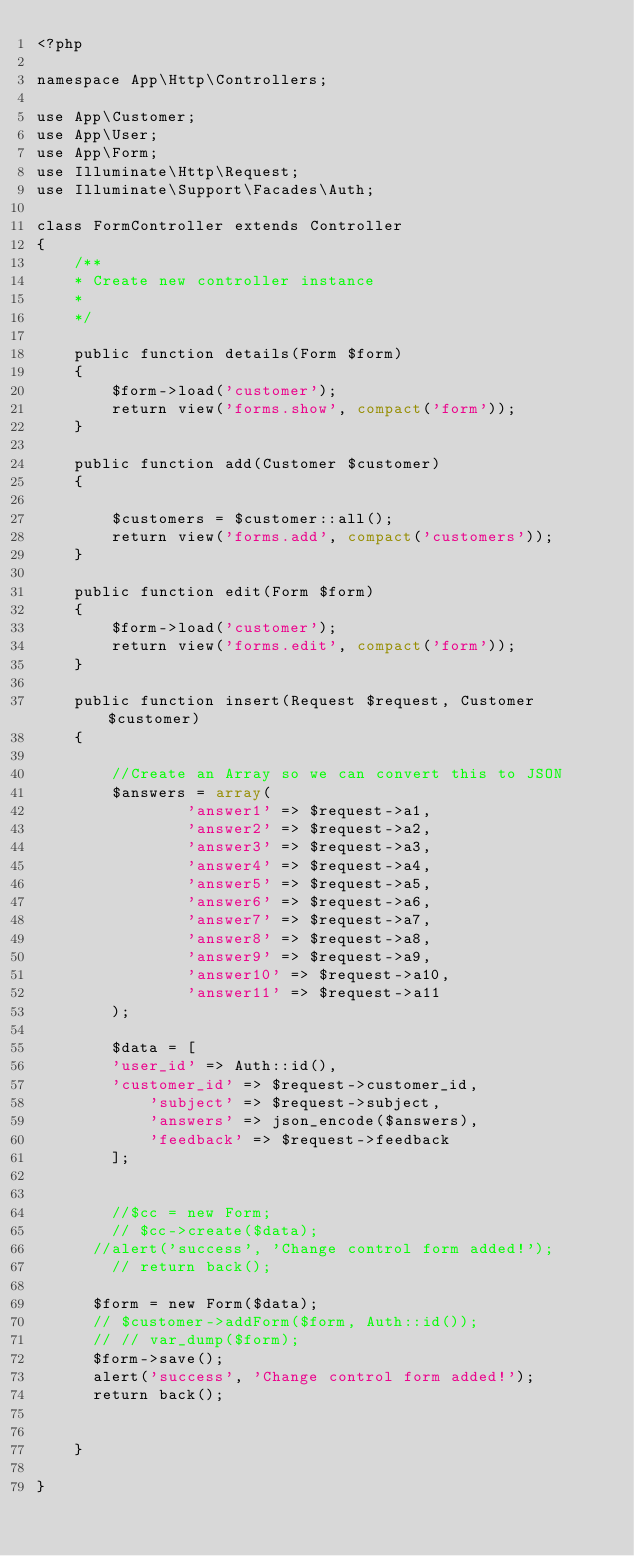Convert code to text. <code><loc_0><loc_0><loc_500><loc_500><_PHP_><?php

namespace App\Http\Controllers;

use App\Customer;
use App\User;
use App\Form;
use Illuminate\Http\Request;
use Illuminate\Support\Facades\Auth;

class FormController extends Controller
{
	/**
	* Create new controller instance
	*
	*/
	
	public function details(Form $form)
	{
		$form->load('customer');
		return view('forms.show', compact('form'));
	}

	public function add(Customer $customer)
	{

		$customers = $customer::all();
		return view('forms.add', compact('customers'));
	}

	public function edit(Form $form)
	{
		$form->load('customer');
		return view('forms.edit', compact('form'));
	}

	public function insert(Request $request, Customer $customer) 
	{

		//Create an Array so we can convert this to JSON
		$answers = array(
				'answer1' => $request->a1,
				'answer2' => $request->a2,
				'answer3' => $request->a3,
				'answer4' => $request->a4,
				'answer5' => $request->a5,
				'answer6' => $request->a6,
				'answer7' => $request->a7,
				'answer8' => $request->a8,
				'answer9' => $request->a9,
				'answer10' => $request->a10,
				'answer11' => $request->a11
		);

		$data = [
		'user_id' => Auth::id(),
		'customer_id' => $request->customer_id,
			'subject' => $request->subject,
			'answers' => json_encode($answers),
			'feedback' => $request->feedback
		];


		//$cc = new Form;
		// $cc->create($data);
	  //alert('success', 'Change control form added!');
		// return back();

	  $form = new Form($data);
	  // $customer->addForm($form, Auth::id());
	  // // var_dump($form);
	  $form->save();
	  alert('success', 'Change control form added!');
	  return back();


	}

}
</code> 